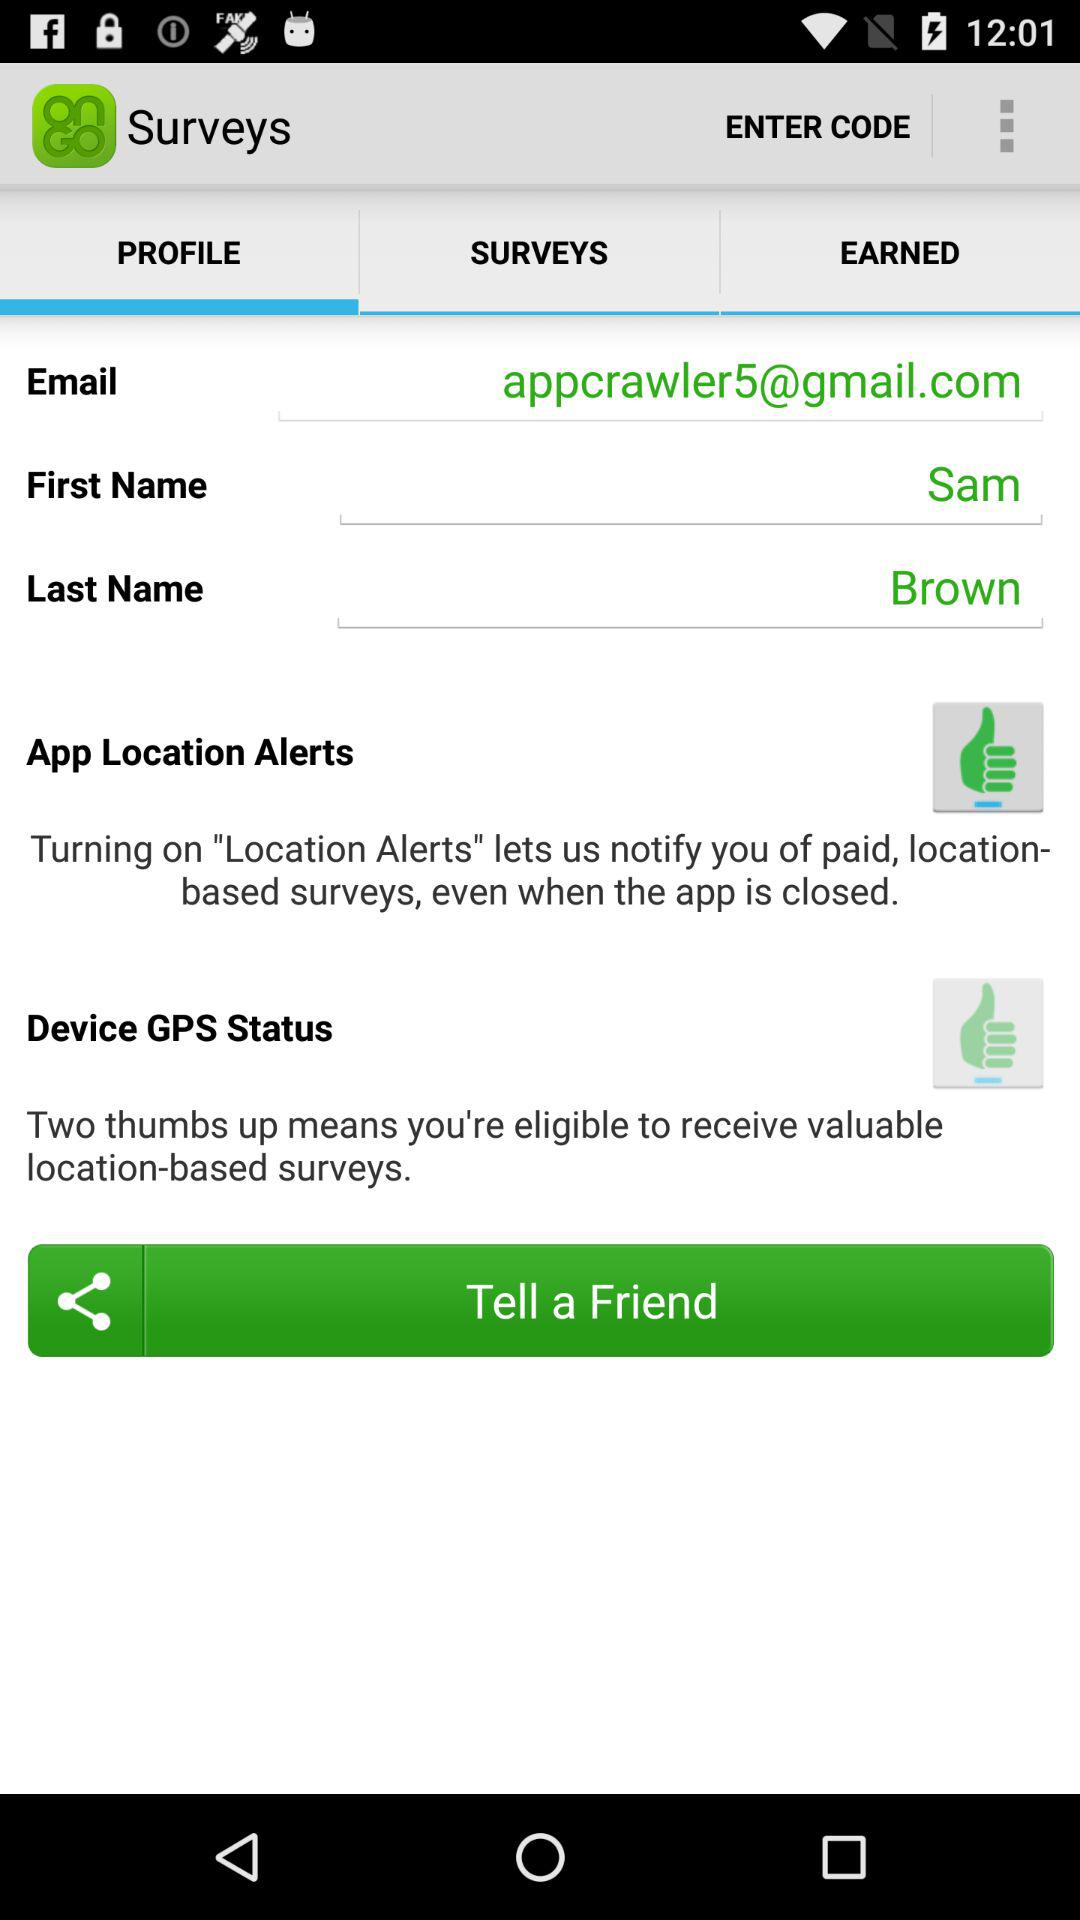Which tab has been selected? The selected tab is "PROFILE". 